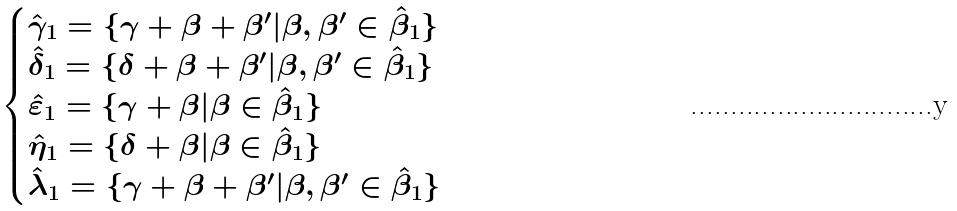<formula> <loc_0><loc_0><loc_500><loc_500>\begin{cases} \hat { \gamma } _ { 1 } = \{ \gamma + \beta + \beta ^ { \prime } | \beta , \beta ^ { \prime } \in \hat { \beta } _ { 1 } \} \\ \hat { \delta } _ { 1 } = \{ \delta + \beta + \beta ^ { \prime } | \beta , \beta ^ { \prime } \in \hat { \beta } _ { 1 } \} \\ \hat { \varepsilon } _ { 1 } = \{ \gamma + \beta | \beta \in \hat { \beta } _ { 1 } \} \\ \hat { \eta } _ { 1 } = \{ \delta + \beta | \beta \in \hat { \beta } _ { 1 } \} \\ \hat { \lambda } _ { 1 } = \{ \gamma + \beta + \beta ^ { \prime } | \beta , \beta ^ { \prime } \in \hat { \beta } _ { 1 } \} \\ \end{cases}</formula> 